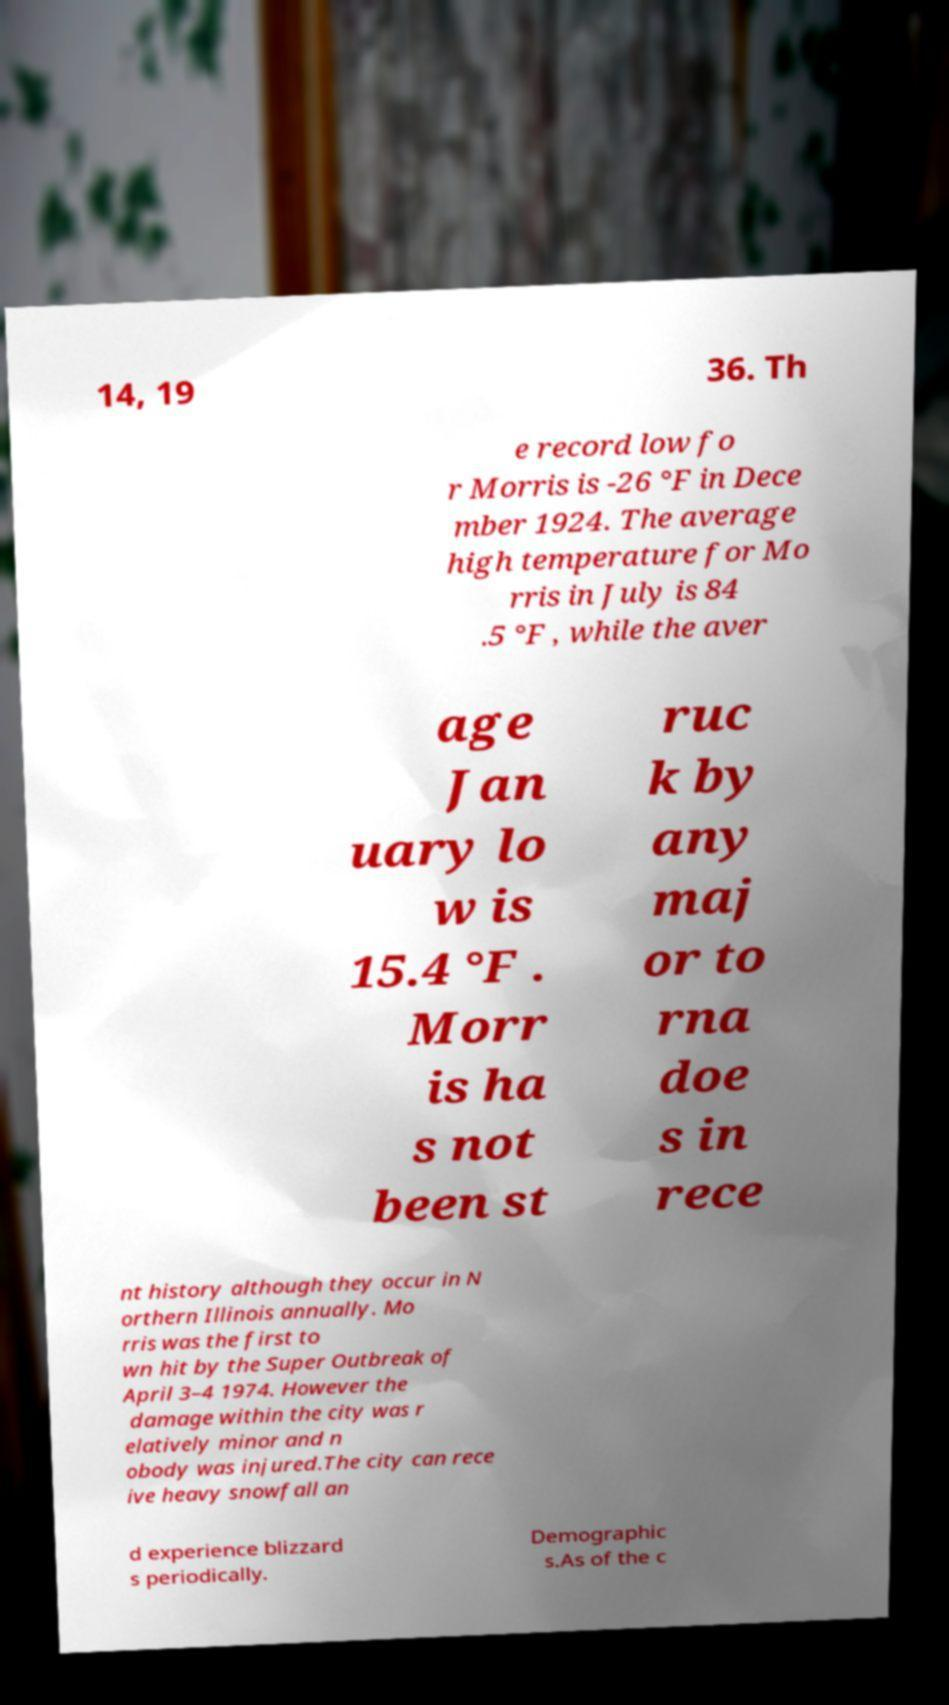There's text embedded in this image that I need extracted. Can you transcribe it verbatim? 14, 19 36. Th e record low fo r Morris is -26 °F in Dece mber 1924. The average high temperature for Mo rris in July is 84 .5 °F , while the aver age Jan uary lo w is 15.4 °F . Morr is ha s not been st ruc k by any maj or to rna doe s in rece nt history although they occur in N orthern Illinois annually. Mo rris was the first to wn hit by the Super Outbreak of April 3–4 1974. However the damage within the city was r elatively minor and n obody was injured.The city can rece ive heavy snowfall an d experience blizzard s periodically. Demographic s.As of the c 